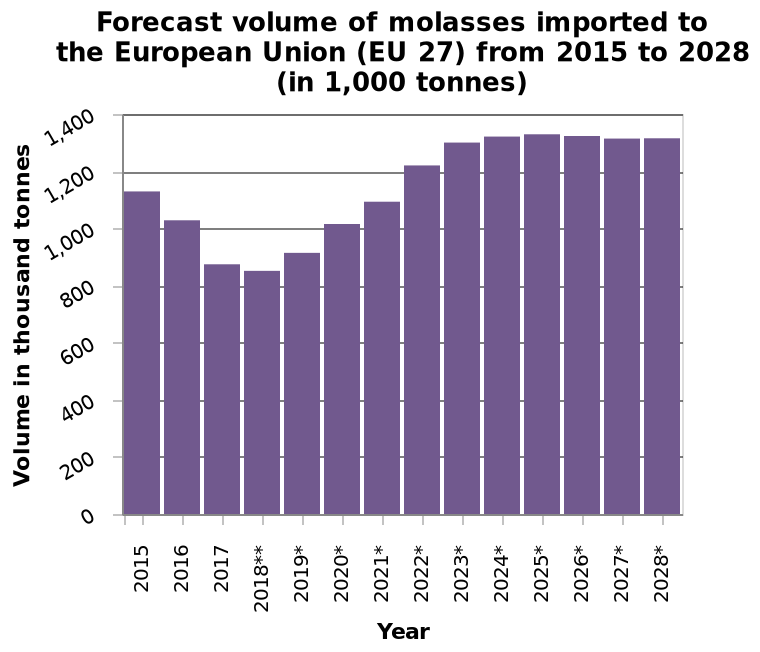<image>
please summary the statistics and relations of the chart From 2023 the level seems to be fairly steady for the rest of the chart. What is the lowest volume of molasses imported to the EU during the given time period? The lowest volume of molasses imported to the EU during the given time period is not specified in the description. Describe the following image in detail Forecast volume of molasses imported to the European Union (EU 27) from 2015 to 2028 (in 1,000 tonnes) is a bar graph. The y-axis shows Volume in thousand tonnes along linear scale from 0 to 1,400 while the x-axis measures Year with categorical scale starting at 2015 and ending at . 